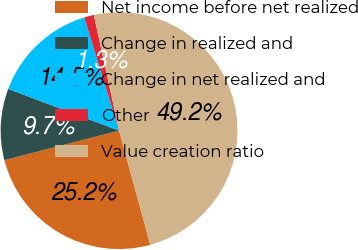Convert chart to OTSL. <chart><loc_0><loc_0><loc_500><loc_500><pie_chart><fcel>Net income before net realized<fcel>Change in realized and<fcel>Change in net realized and<fcel>Other<fcel>Value creation ratio<nl><fcel>25.24%<fcel>9.74%<fcel>14.53%<fcel>1.33%<fcel>49.16%<nl></chart> 